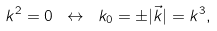<formula> <loc_0><loc_0><loc_500><loc_500>k ^ { 2 } = 0 \ \leftrightarrow \ k _ { 0 } = \pm | \vec { k } | = k ^ { 3 } ,</formula> 